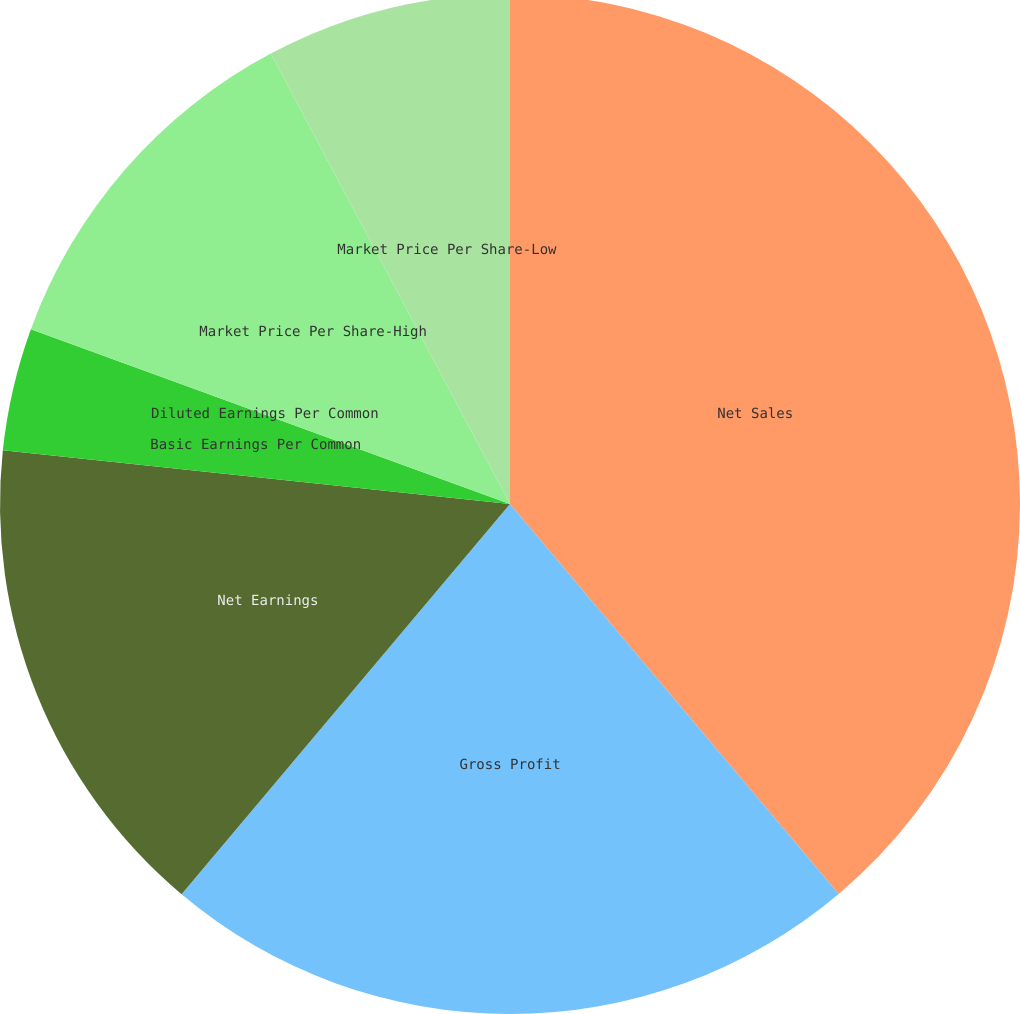Convert chart. <chart><loc_0><loc_0><loc_500><loc_500><pie_chart><fcel>Net Sales<fcel>Gross Profit<fcel>Net Earnings<fcel>Basic Earnings Per Common<fcel>Diluted Earnings Per Common<fcel>Market Price Per Share-High<fcel>Market Price Per Share-Low<nl><fcel>38.85%<fcel>22.28%<fcel>15.54%<fcel>3.89%<fcel>0.0%<fcel>11.66%<fcel>7.77%<nl></chart> 